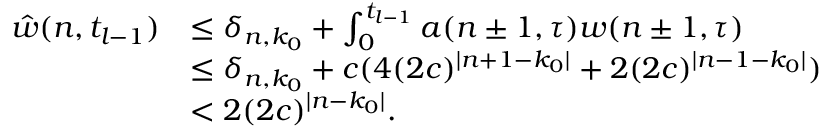Convert formula to latex. <formula><loc_0><loc_0><loc_500><loc_500>\begin{array} { r l } { \hat { w } ( n , t _ { l - 1 } ) } & { \leq \delta _ { n , k _ { 0 } } + \int _ { 0 } ^ { t _ { l - 1 } } a ( n \pm 1 , \tau ) w ( n \pm 1 , \tau ) } \\ & { \leq \delta _ { n , k _ { 0 } } + c ( 4 ( 2 c ) ^ { | n + 1 - k _ { 0 } | } + 2 ( 2 c ) ^ { | n - 1 - k _ { 0 } | } ) } \\ & { < 2 ( 2 c ) ^ { | n - k _ { 0 } | } . } \end{array}</formula> 